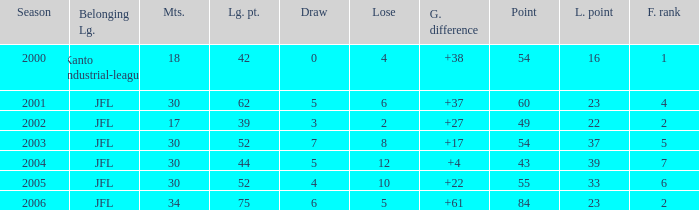Tell me the average final rank for loe more than 10 and point less than 43 None. 